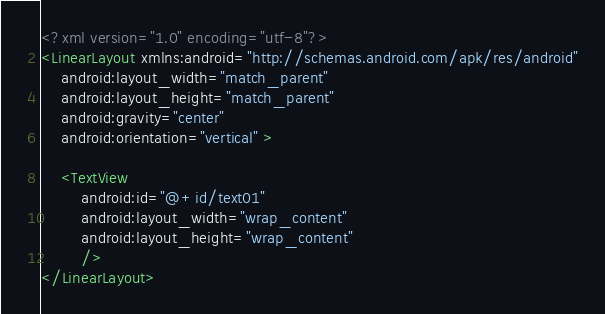Convert code to text. <code><loc_0><loc_0><loc_500><loc_500><_XML_><?xml version="1.0" encoding="utf-8"?>
<LinearLayout xmlns:android="http://schemas.android.com/apk/res/android"
    android:layout_width="match_parent"
    android:layout_height="match_parent"
    android:gravity="center"
    android:orientation="vertical" >
    
	<TextView 
	    android:id="@+id/text01"
	    android:layout_width="wrap_content"
	    android:layout_height="wrap_content"
	    />
</LinearLayout>
</code> 